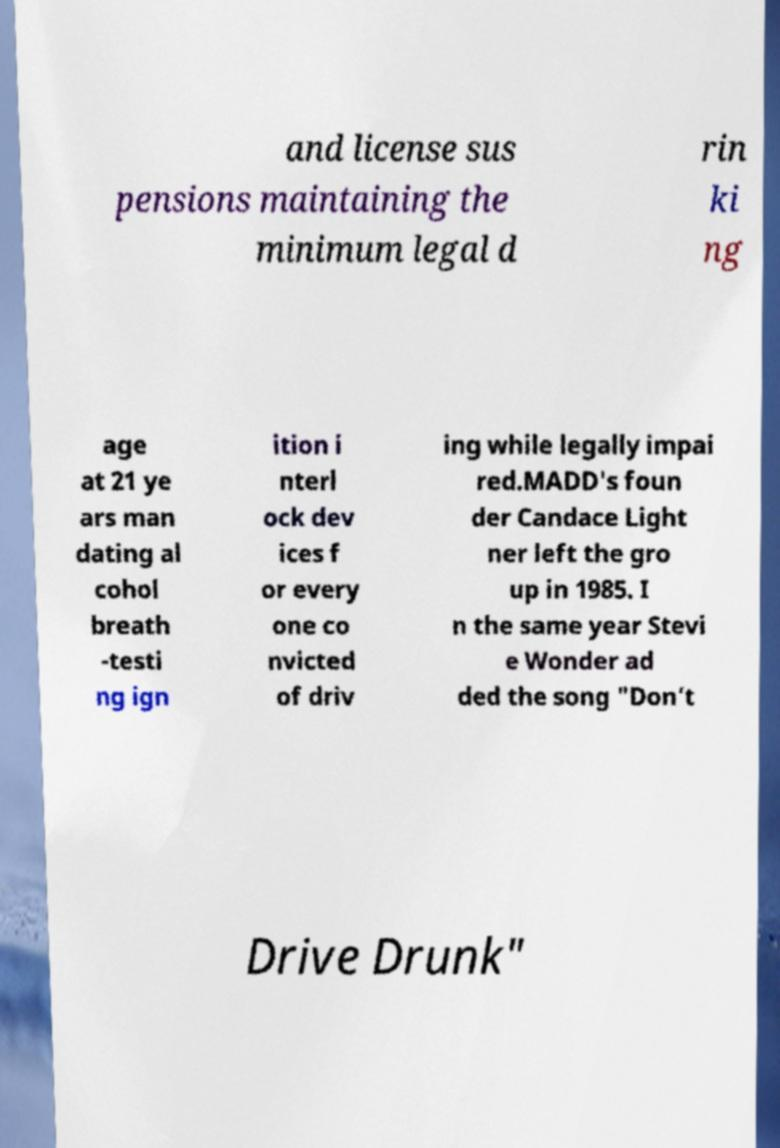Could you assist in decoding the text presented in this image and type it out clearly? and license sus pensions maintaining the minimum legal d rin ki ng age at 21 ye ars man dating al cohol breath -testi ng ign ition i nterl ock dev ices f or every one co nvicted of driv ing while legally impai red.MADD's foun der Candace Light ner left the gro up in 1985. I n the same year Stevi e Wonder ad ded the song "Don’t Drive Drunk" 